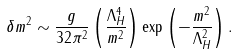Convert formula to latex. <formula><loc_0><loc_0><loc_500><loc_500>\delta m ^ { 2 } \sim \frac { g } { 3 2 \pi ^ { 2 } } \left ( \frac { \Lambda ^ { 4 } _ { H } } { m ^ { 2 } } \right ) \exp \left ( - \frac { m ^ { 2 } } { \Lambda _ { H } ^ { 2 } } \right ) .</formula> 